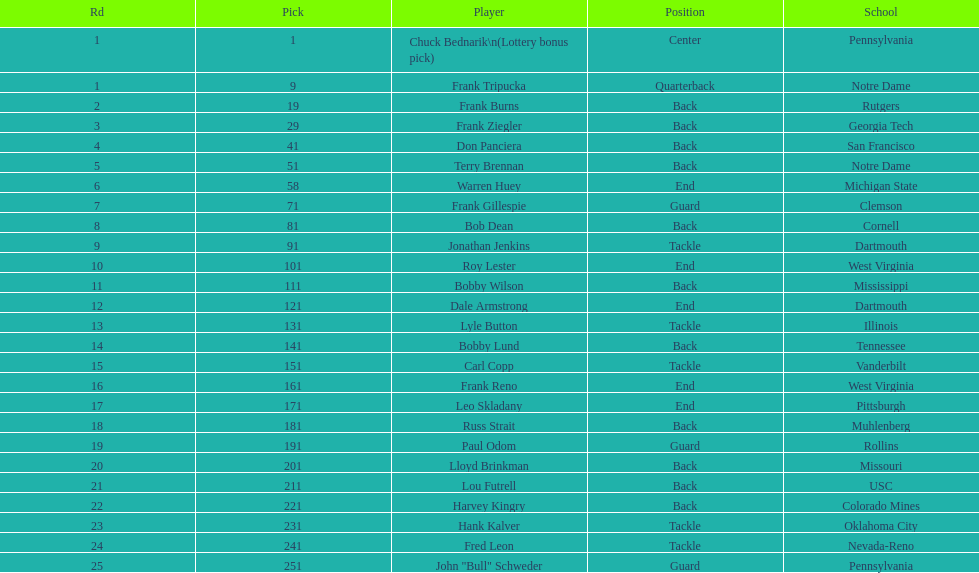Which player did the team draft subsequent to bob dean? Jonathan Jenkins. 